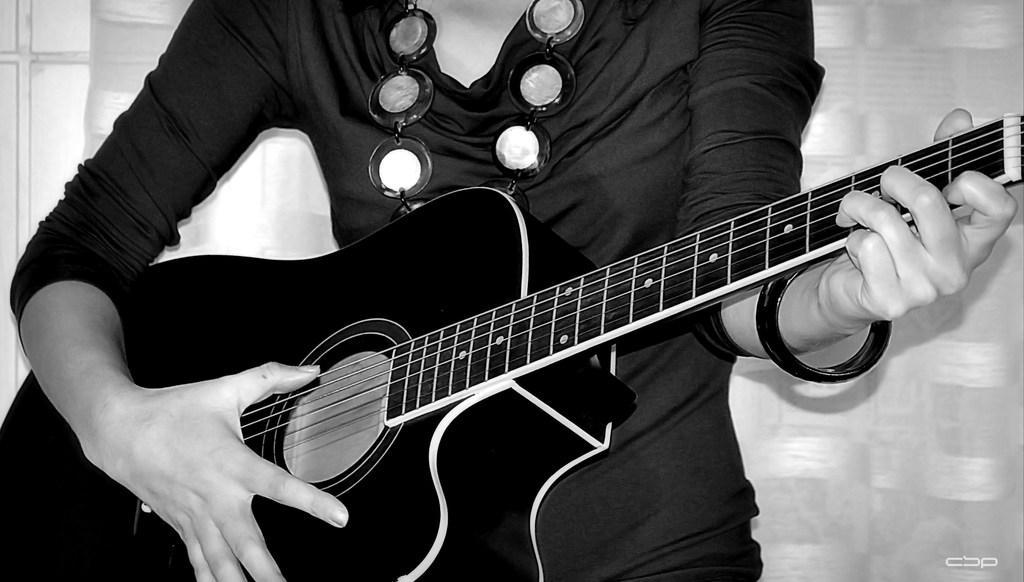Can you describe this image briefly? In this image, human is holding a guitar. She is playing a guitar. On his left hand, we can see bangle. At the background, there is a curtain. She wear a dress and there is a necklace on his neck. 